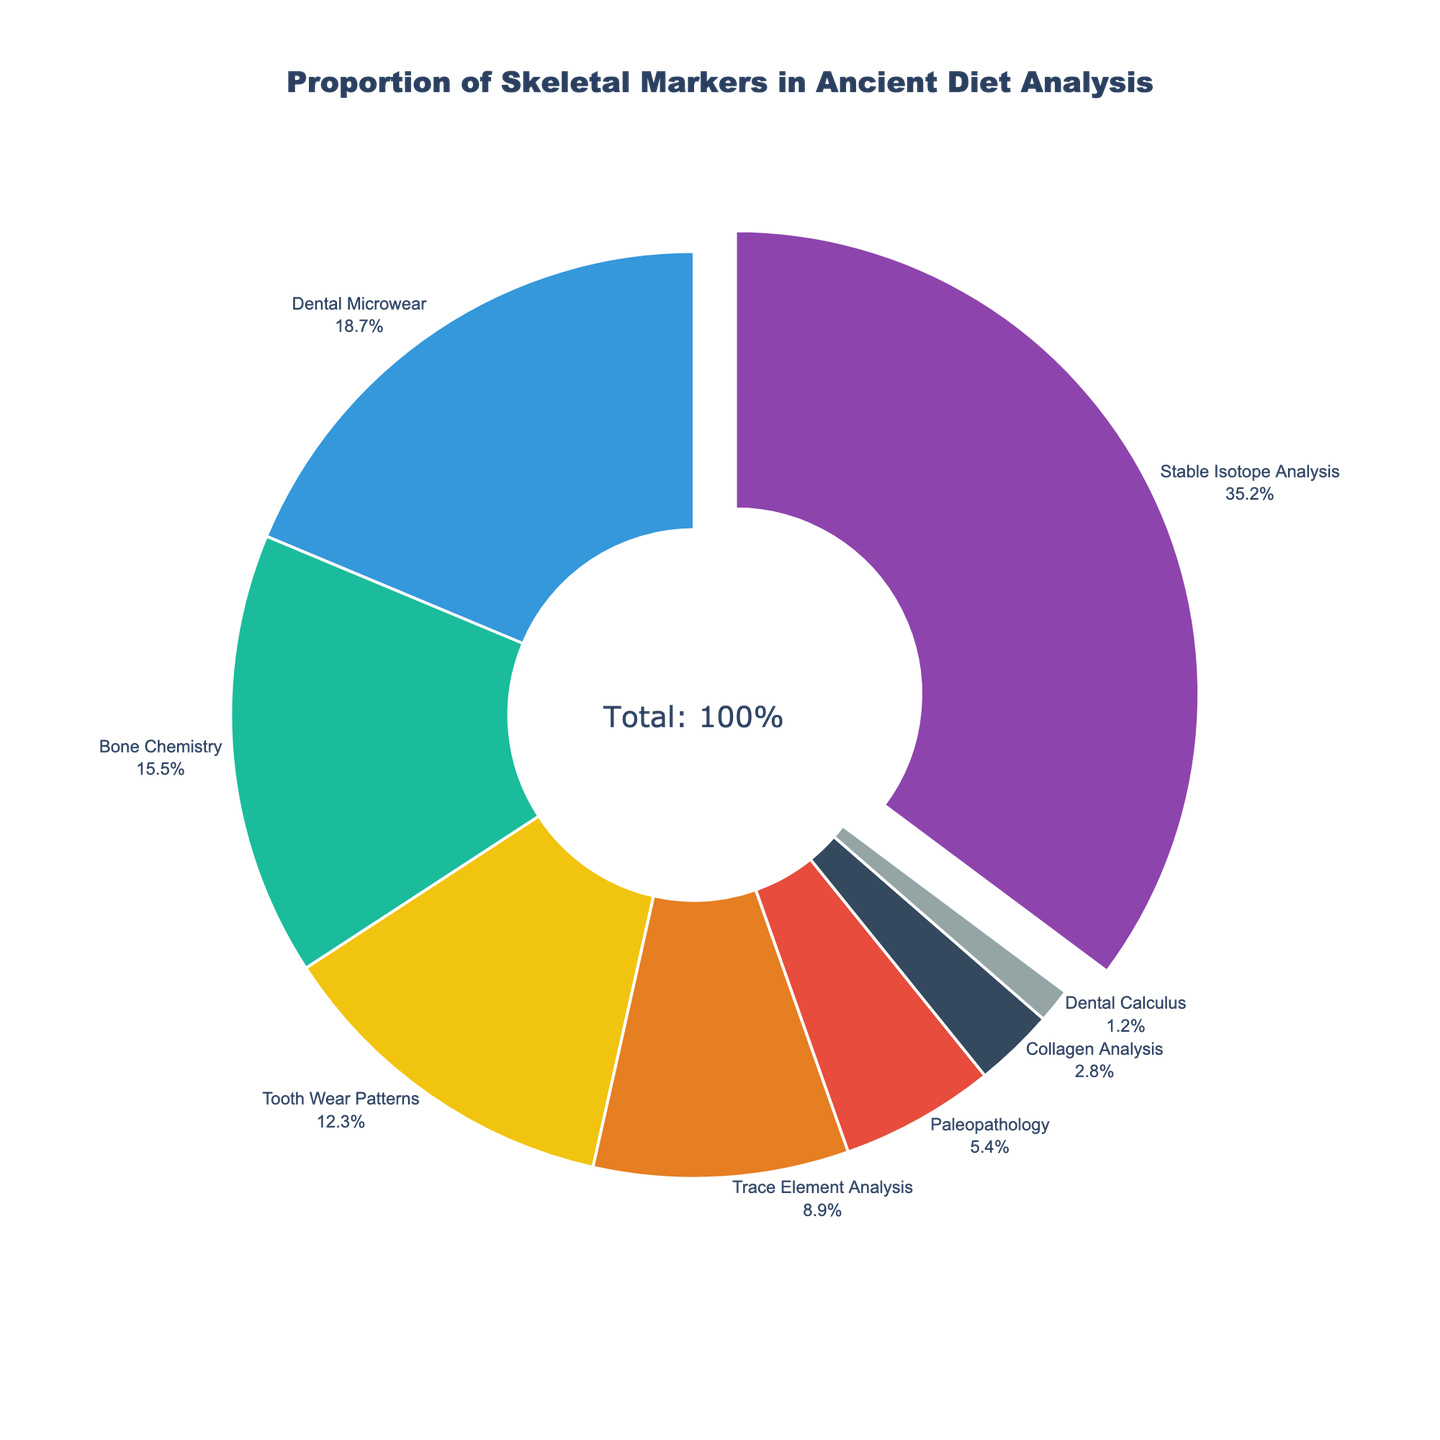What's the proportion of Stable Isotope Analysis compared to Bone Chemistry? To find the proportion of Stable Isotope Analysis compared to Bone Chemistry, we need to take the value of Stable Isotope Analysis (35.2%) and the value of Bone Chemistry (15.5%) and compare them. Hence, (35.2 / 15.5) ≈ 2.27.
Answer: 2.27 times Which two skeletal markers contribute to nearly one-third (33.3%) of the total proportion? Summing different combinations of skeletal markers: Stable Isotope Analysis (35.2%) is already greater than 33.3%. The two next largest markers are Dental Microwear (18.7%) and Bone Chemistry (15.5%), which sum to 34.2%.
Answer: Dental Microwear and Bone Chemistry How much higher is the proportion of Trace Element Analysis compared to Collagen Analysis? Subtract the proportion of Collagen Analysis (2.8%) from Trace Element Analysis (8.9%). This gives 8.9 - 2.8 = 6.1%.
Answer: 6.1% What's the total proportion of markers related to dental analysis? Add the proportions of Dental Microwear (18.7%), Tooth Wear Patterns (12.3%), and Dental Calculus (1.2%). This totals 18.7 + 12.3 + 1.2 = 32.2%.
Answer: 32.2% Which skeletal marker has the smallest proportion and what is its percentage? The smallest proportion is Dental Calculus with 1.2% as shown in the figure.
Answer: Dental Calculus, 1.2% Are there any skeletal markers with proportions between 10% and 20%? If so, which ones and what are their proportions? Looking at the figure, Dental Microwear (18.7%) and Tooth Wear Patterns (12.3%) fall between 10% and 20%.
Answer: Dental Microwear (18.7%) and Tooth Wear Patterns (12.3%) What is the combined proportion of Paleopathology and Collagen Analysis? Add the proportions of Paleopathology (5.4%) and Collagen Analysis (2.8%). This totals 5.4 + 2.8 = 8.2%.
Answer: 8.2% Which skeletal marker has the largest proportion, and what is its percentage? The marker with the largest proportion is Stable Isotope Analysis, occupying 35.2% of the total as shown in the figure.
Answer: Stable Isotope Analysis, 35.2% 